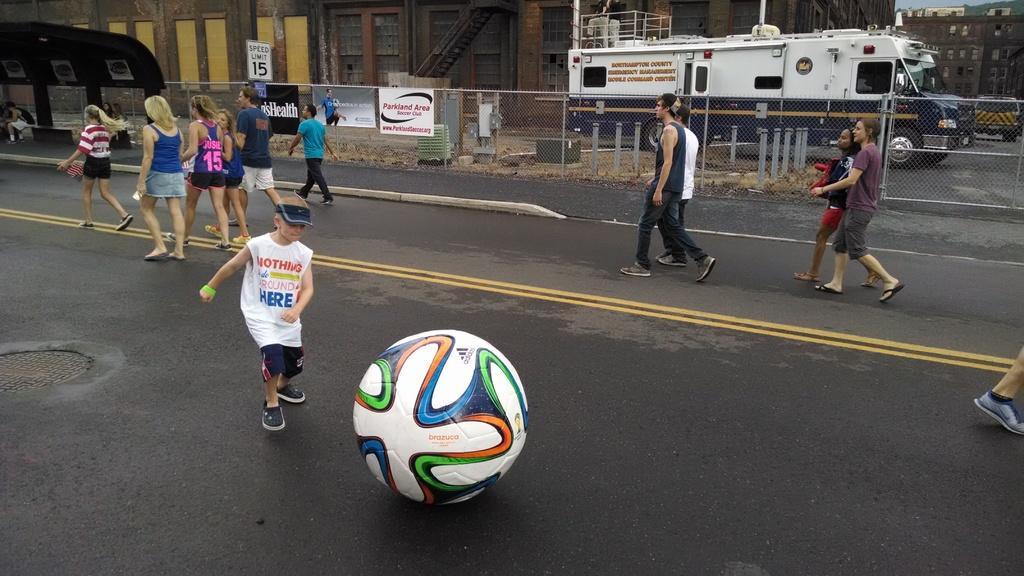How would you summarize this image in a sentence or two? In this image I can see a road in the front and on it I can see number of people are walking. I can also see a white colour football on the road. In the background I can see fencing, few vehicles, few buildings, number of boards, few poles and on these boards I can see something is written. 